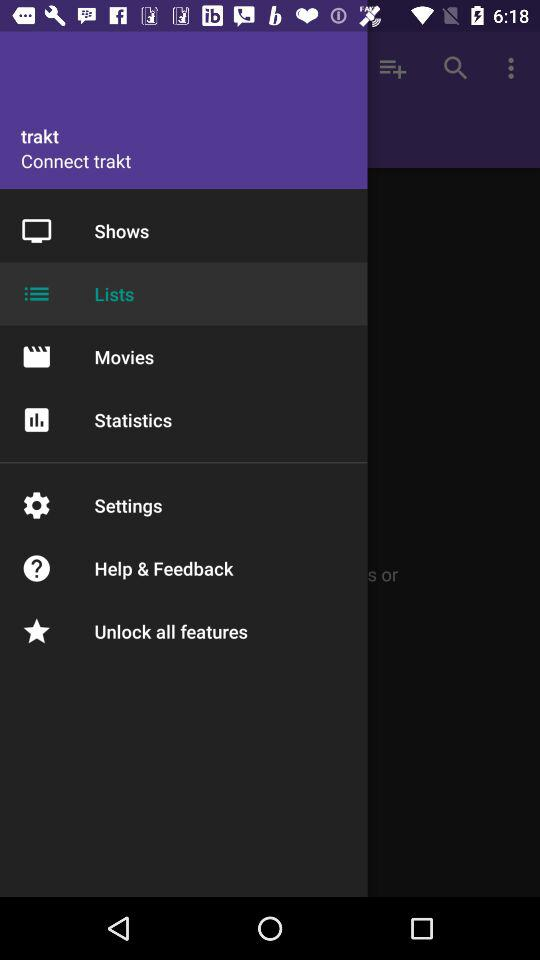What is the user name?
When the provided information is insufficient, respond with <no answer>. <no answer> 